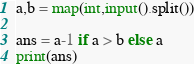Convert code to text. <code><loc_0><loc_0><loc_500><loc_500><_Python_>a,b = map(int,input().split())

ans = a-1 if a > b else a
print(ans)</code> 